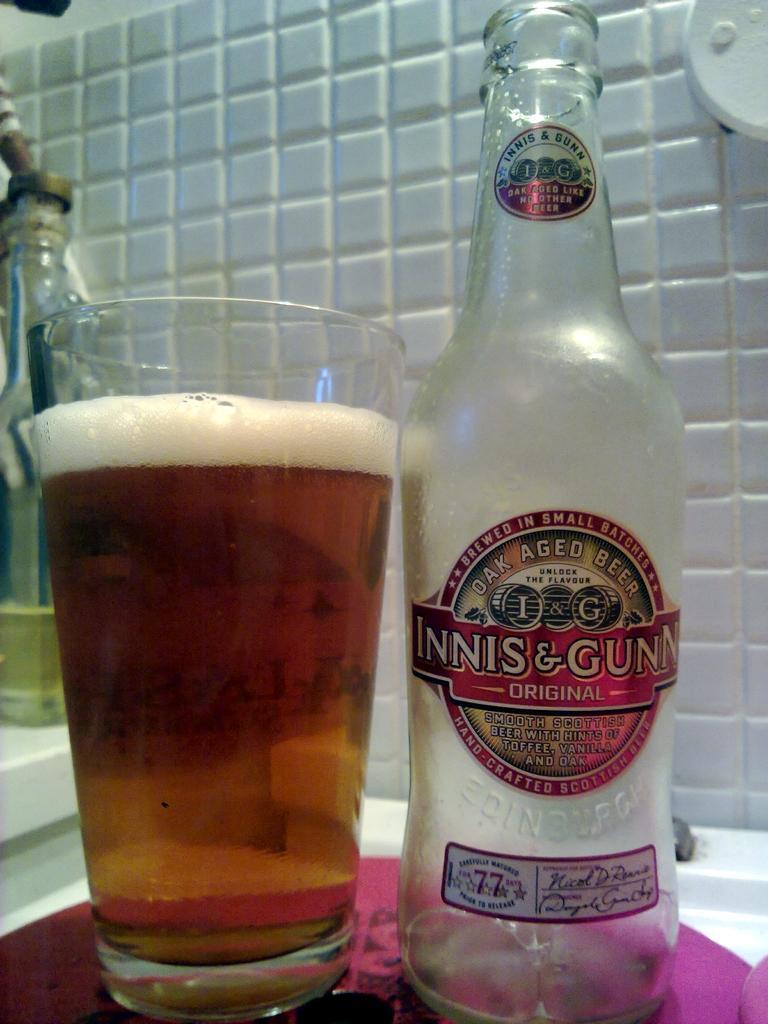Could you give a brief overview of what you see in this image? There is a glass bottle and a glass of wine placed on a table and the background is white in color. 